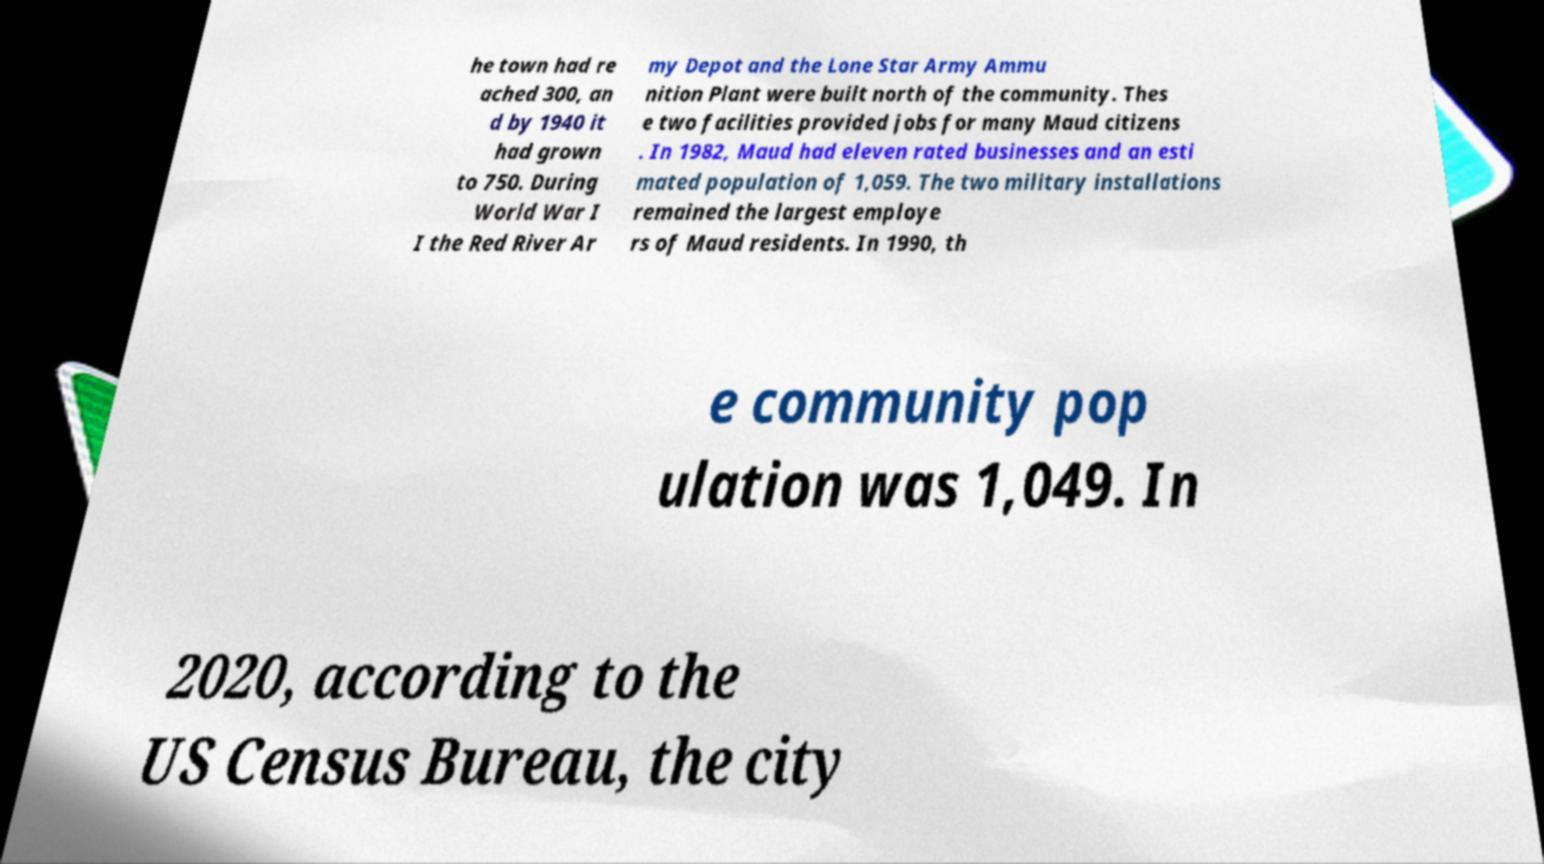I need the written content from this picture converted into text. Can you do that? he town had re ached 300, an d by 1940 it had grown to 750. During World War I I the Red River Ar my Depot and the Lone Star Army Ammu nition Plant were built north of the community. Thes e two facilities provided jobs for many Maud citizens . In 1982, Maud had eleven rated businesses and an esti mated population of 1,059. The two military installations remained the largest employe rs of Maud residents. In 1990, th e community pop ulation was 1,049. In 2020, according to the US Census Bureau, the city 